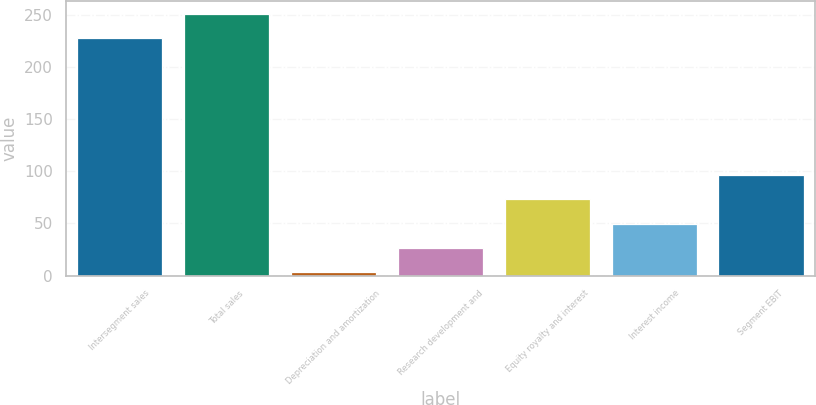Convert chart. <chart><loc_0><loc_0><loc_500><loc_500><bar_chart><fcel>Intersegment sales<fcel>Total sales<fcel>Depreciation and amortization<fcel>Research development and<fcel>Equity royalty and interest<fcel>Interest income<fcel>Segment EBIT<nl><fcel>228<fcel>251.4<fcel>3<fcel>26.4<fcel>73.2<fcel>49.8<fcel>96.6<nl></chart> 